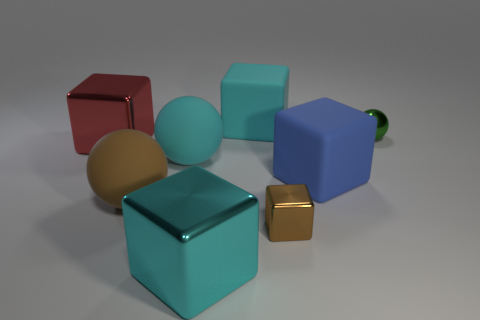What number of brown things are either tiny shiny balls or big matte things? In the image, there are two brown items: one is a small shiny ball, and the other is a large matte cube. Therefore, the correct count of brown items that are either tiny shiny balls or big matte things is 2. 